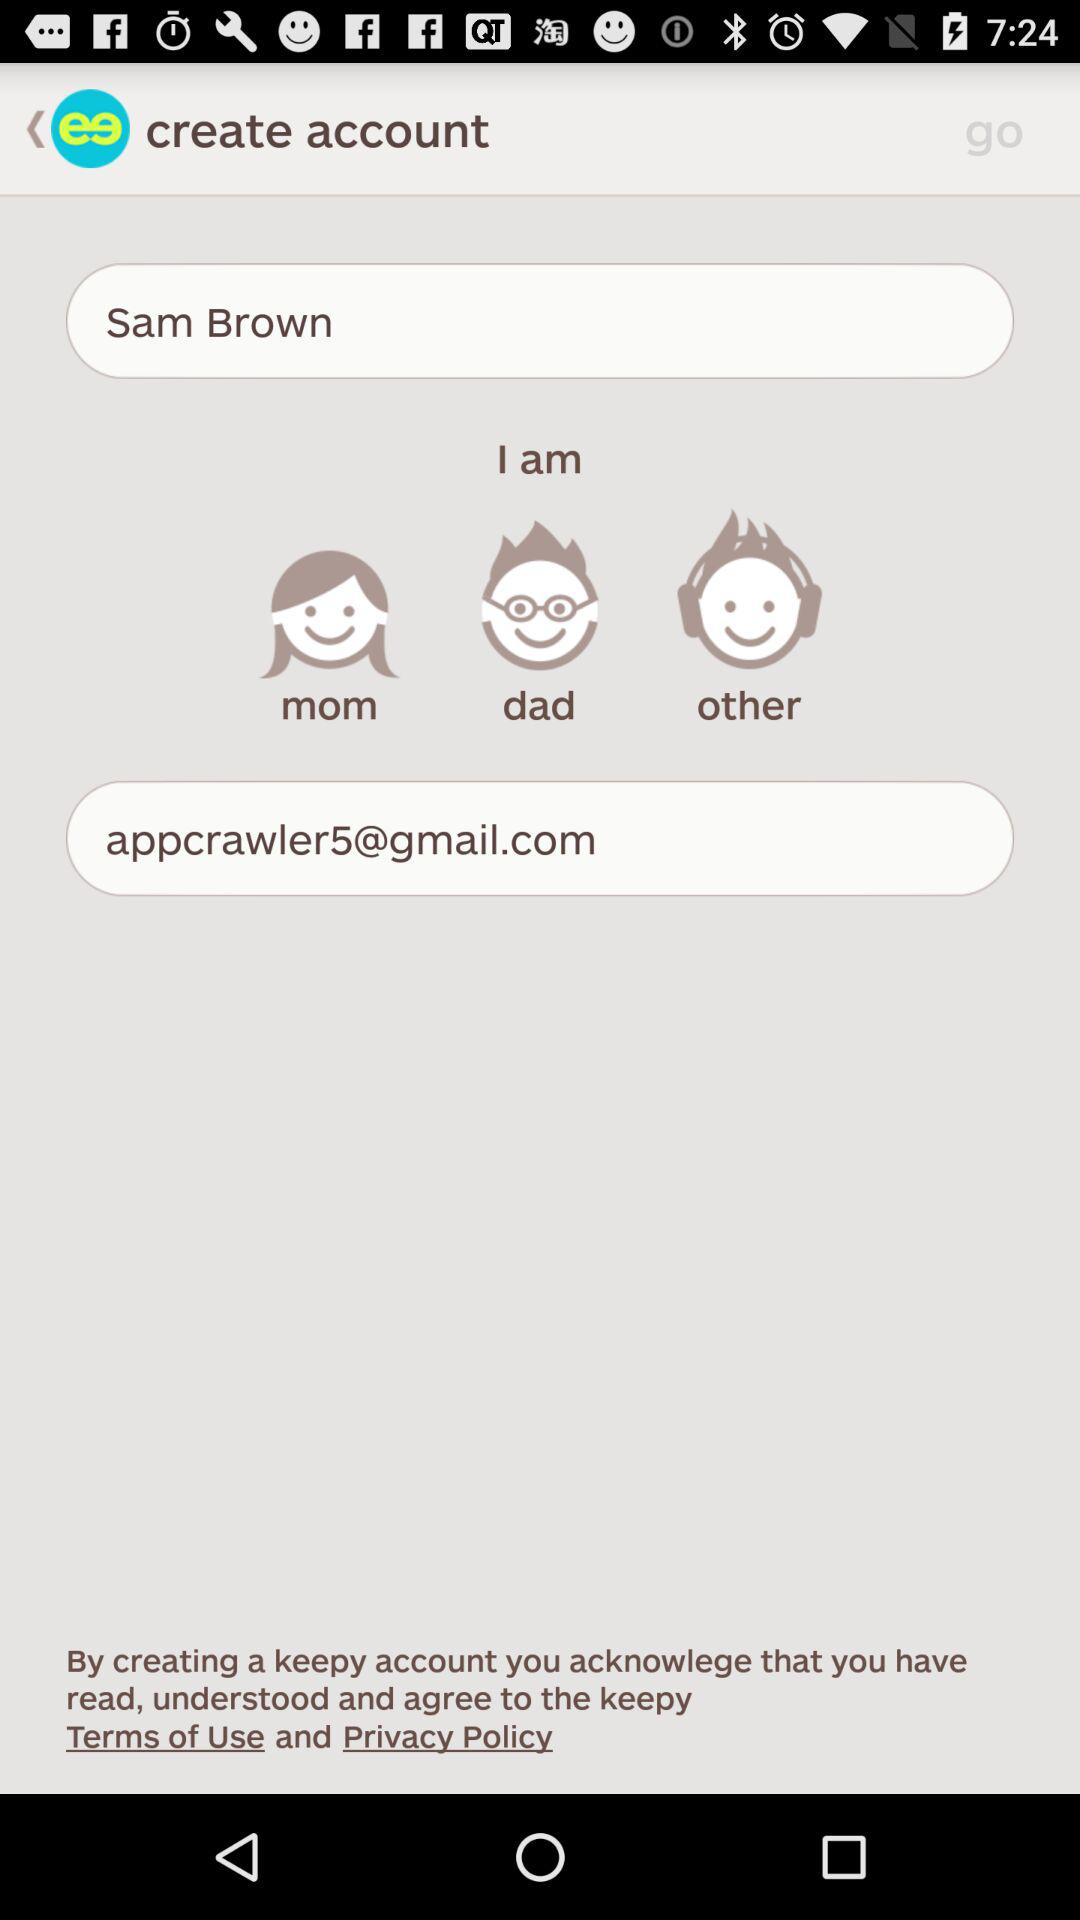What is the entered email address? The entered email address is appcrawler5@gmail.com. 